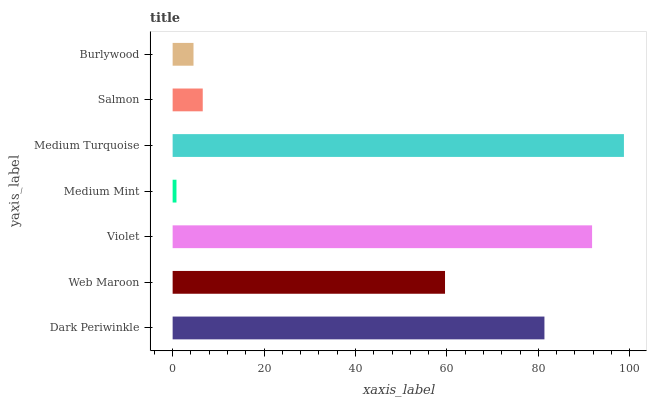Is Medium Mint the minimum?
Answer yes or no. Yes. Is Medium Turquoise the maximum?
Answer yes or no. Yes. Is Web Maroon the minimum?
Answer yes or no. No. Is Web Maroon the maximum?
Answer yes or no. No. Is Dark Periwinkle greater than Web Maroon?
Answer yes or no. Yes. Is Web Maroon less than Dark Periwinkle?
Answer yes or no. Yes. Is Web Maroon greater than Dark Periwinkle?
Answer yes or no. No. Is Dark Periwinkle less than Web Maroon?
Answer yes or no. No. Is Web Maroon the high median?
Answer yes or no. Yes. Is Web Maroon the low median?
Answer yes or no. Yes. Is Salmon the high median?
Answer yes or no. No. Is Medium Turquoise the low median?
Answer yes or no. No. 